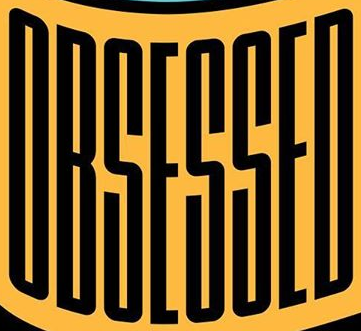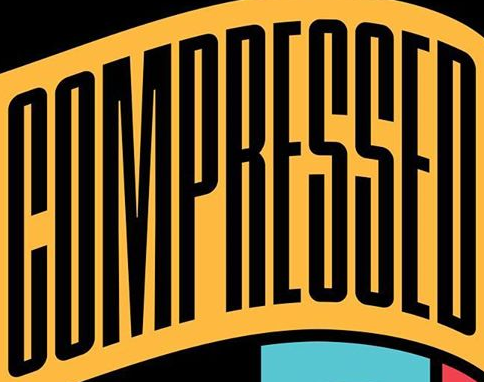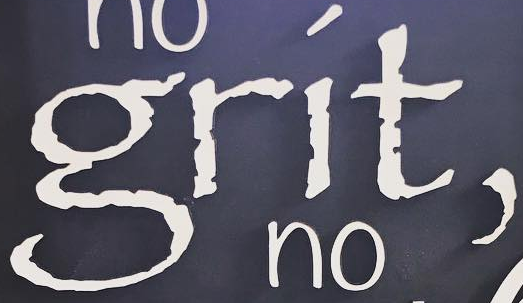Read the text content from these images in order, separated by a semicolon. OBSESSED; COMPRESSED; grít, 